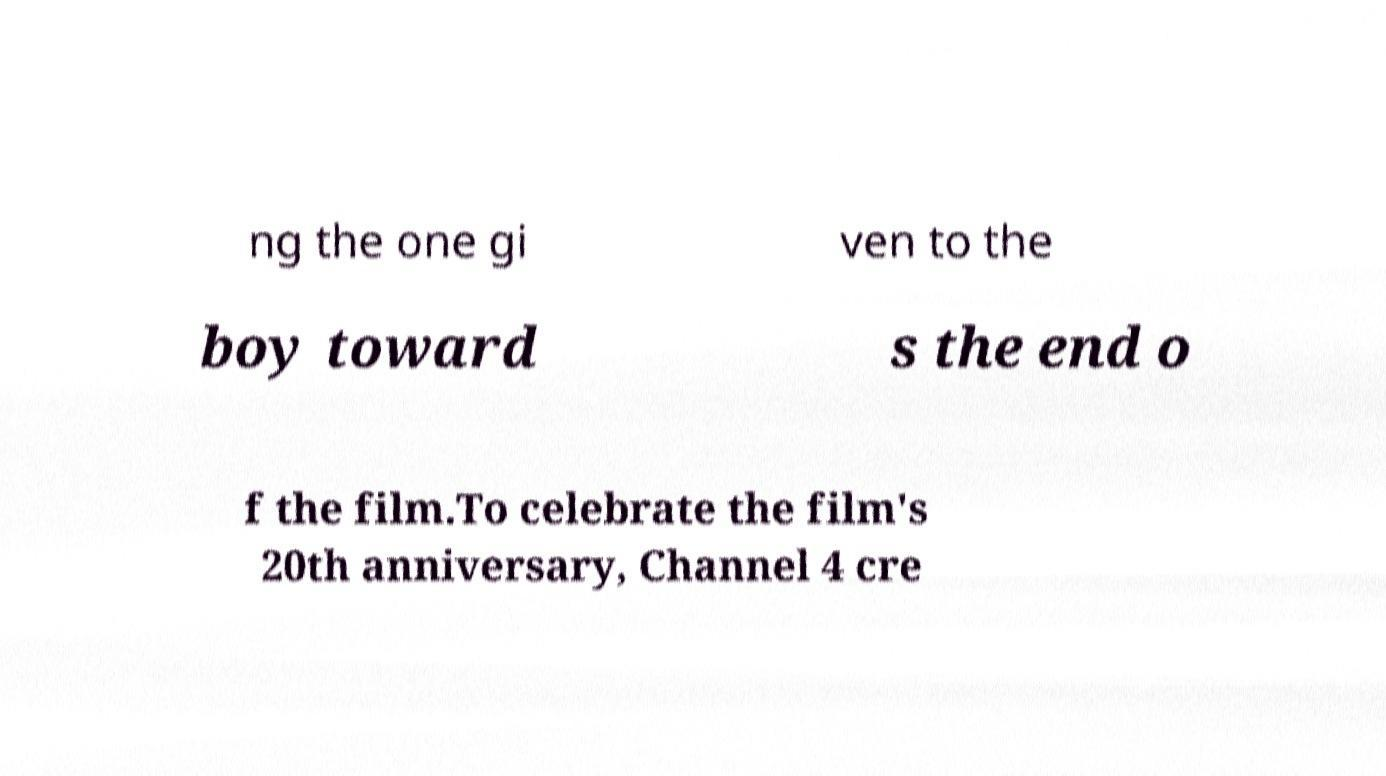There's text embedded in this image that I need extracted. Can you transcribe it verbatim? ng the one gi ven to the boy toward s the end o f the film.To celebrate the film's 20th anniversary, Channel 4 cre 